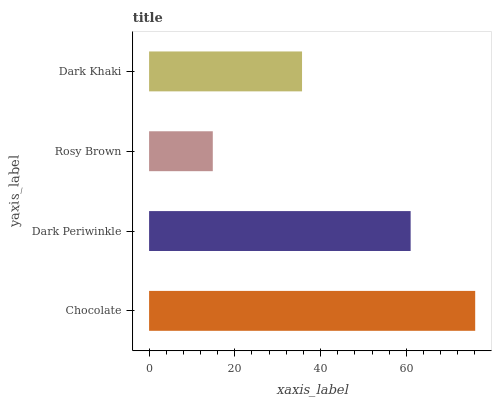Is Rosy Brown the minimum?
Answer yes or no. Yes. Is Chocolate the maximum?
Answer yes or no. Yes. Is Dark Periwinkle the minimum?
Answer yes or no. No. Is Dark Periwinkle the maximum?
Answer yes or no. No. Is Chocolate greater than Dark Periwinkle?
Answer yes or no. Yes. Is Dark Periwinkle less than Chocolate?
Answer yes or no. Yes. Is Dark Periwinkle greater than Chocolate?
Answer yes or no. No. Is Chocolate less than Dark Periwinkle?
Answer yes or no. No. Is Dark Periwinkle the high median?
Answer yes or no. Yes. Is Dark Khaki the low median?
Answer yes or no. Yes. Is Dark Khaki the high median?
Answer yes or no. No. Is Rosy Brown the low median?
Answer yes or no. No. 